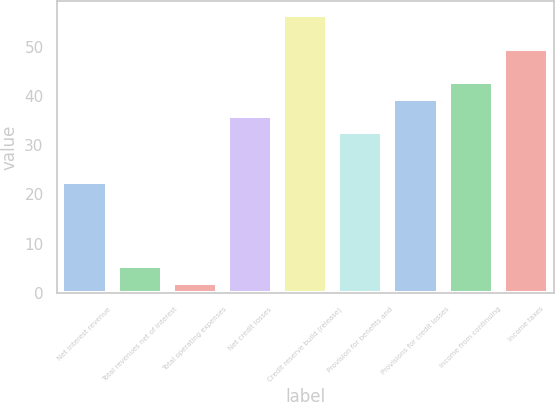<chart> <loc_0><loc_0><loc_500><loc_500><bar_chart><fcel>Net interest revenue<fcel>Total revenues net of interest<fcel>Total operating expenses<fcel>Net credit losses<fcel>Credit reserve build (release)<fcel>Provision for benefits and<fcel>Provisions for credit losses<fcel>Income from continuing<fcel>Income taxes<nl><fcel>22.4<fcel>5.4<fcel>2<fcel>36<fcel>56.4<fcel>32.6<fcel>39.4<fcel>42.8<fcel>49.6<nl></chart> 